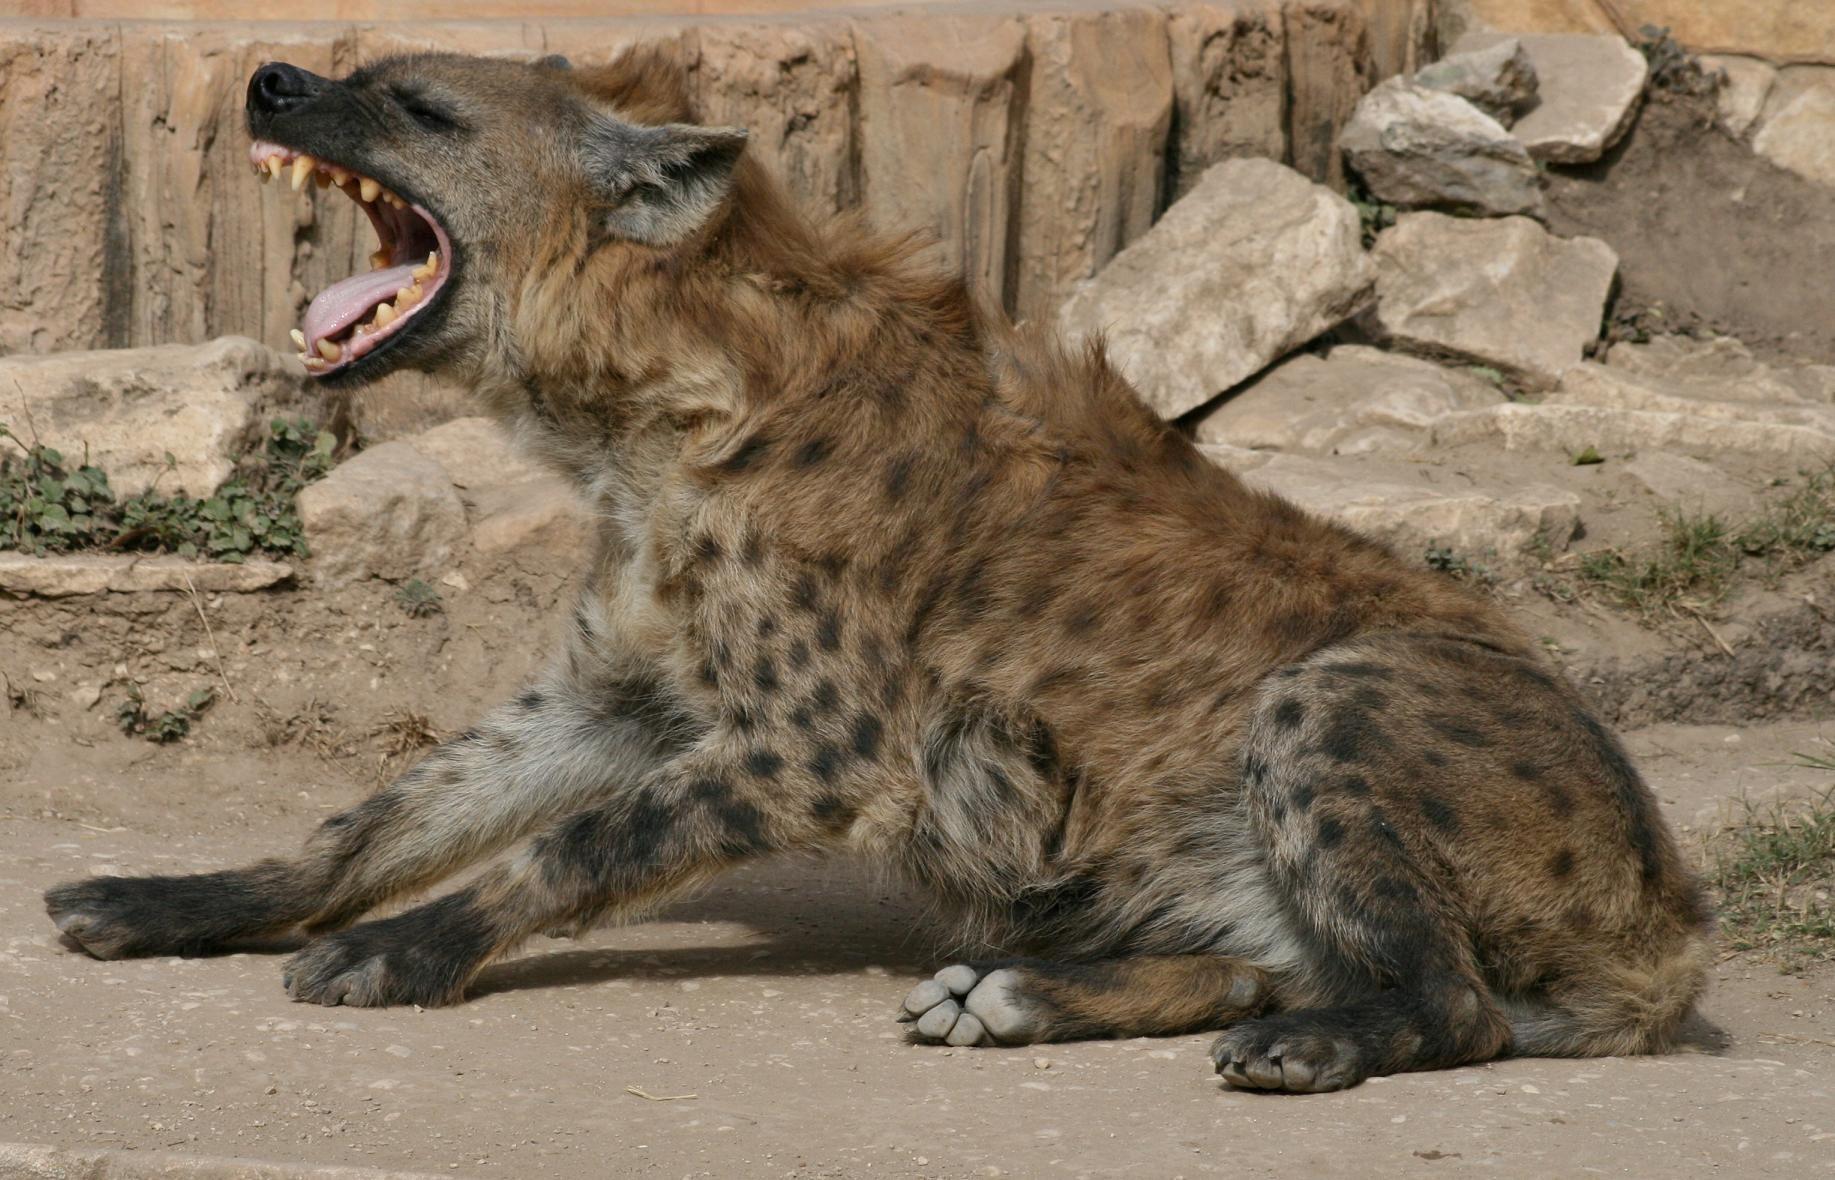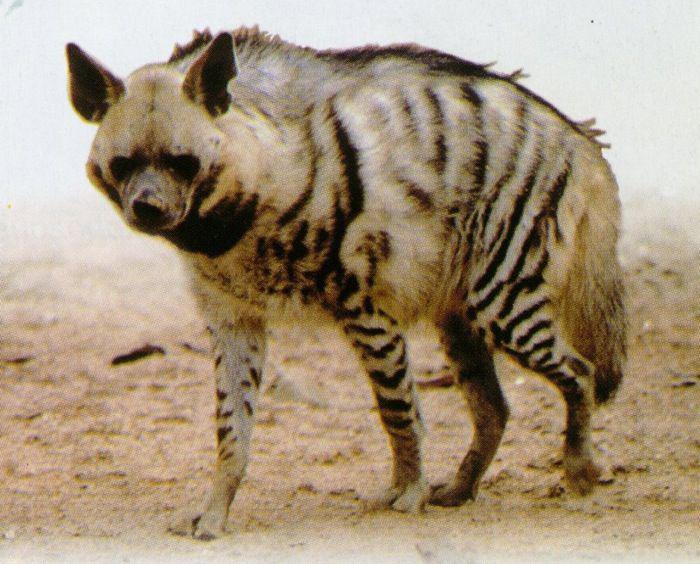The first image is the image on the left, the second image is the image on the right. Analyze the images presented: Is the assertion "There is an animal with its mouth open in one of the images." valid? Answer yes or no. Yes. 